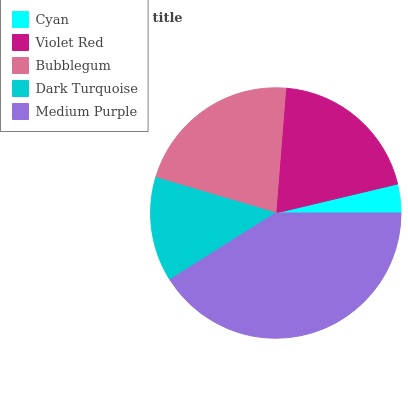Is Cyan the minimum?
Answer yes or no. Yes. Is Medium Purple the maximum?
Answer yes or no. Yes. Is Violet Red the minimum?
Answer yes or no. No. Is Violet Red the maximum?
Answer yes or no. No. Is Violet Red greater than Cyan?
Answer yes or no. Yes. Is Cyan less than Violet Red?
Answer yes or no. Yes. Is Cyan greater than Violet Red?
Answer yes or no. No. Is Violet Red less than Cyan?
Answer yes or no. No. Is Violet Red the high median?
Answer yes or no. Yes. Is Violet Red the low median?
Answer yes or no. Yes. Is Bubblegum the high median?
Answer yes or no. No. Is Dark Turquoise the low median?
Answer yes or no. No. 